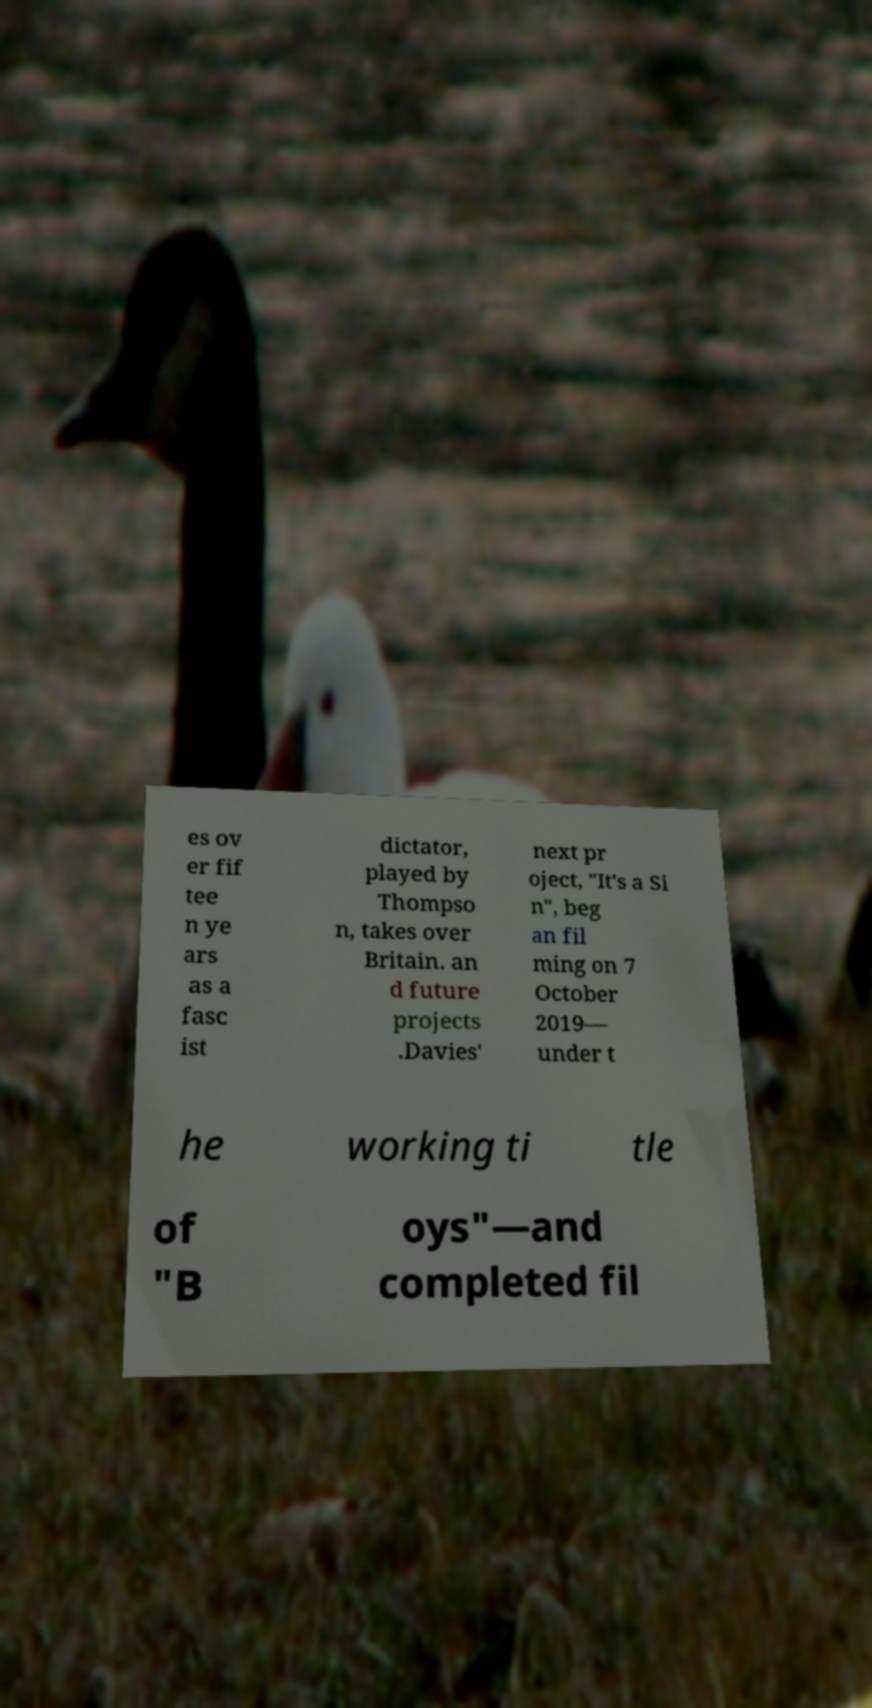Please read and relay the text visible in this image. What does it say? es ov er fif tee n ye ars as a fasc ist dictator, played by Thompso n, takes over Britain. an d future projects .Davies' next pr oject, "It's a Si n", beg an fil ming on 7 October 2019— under t he working ti tle of "B oys"—and completed fil 